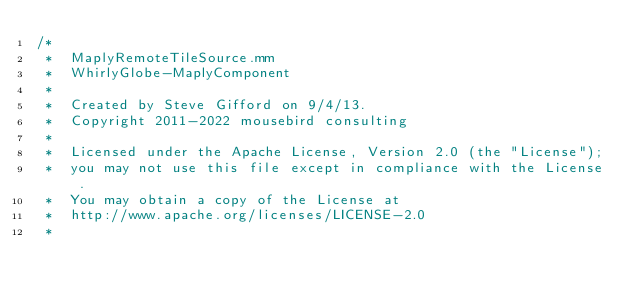<code> <loc_0><loc_0><loc_500><loc_500><_ObjectiveC_>/*
 *  MaplyRemoteTileSource.mm
 *  WhirlyGlobe-MaplyComponent
 *
 *  Created by Steve Gifford on 9/4/13.
 *  Copyright 2011-2022 mousebird consulting
 *
 *  Licensed under the Apache License, Version 2.0 (the "License");
 *  you may not use this file except in compliance with the License.
 *  You may obtain a copy of the License at
 *  http://www.apache.org/licenses/LICENSE-2.0
 *</code> 